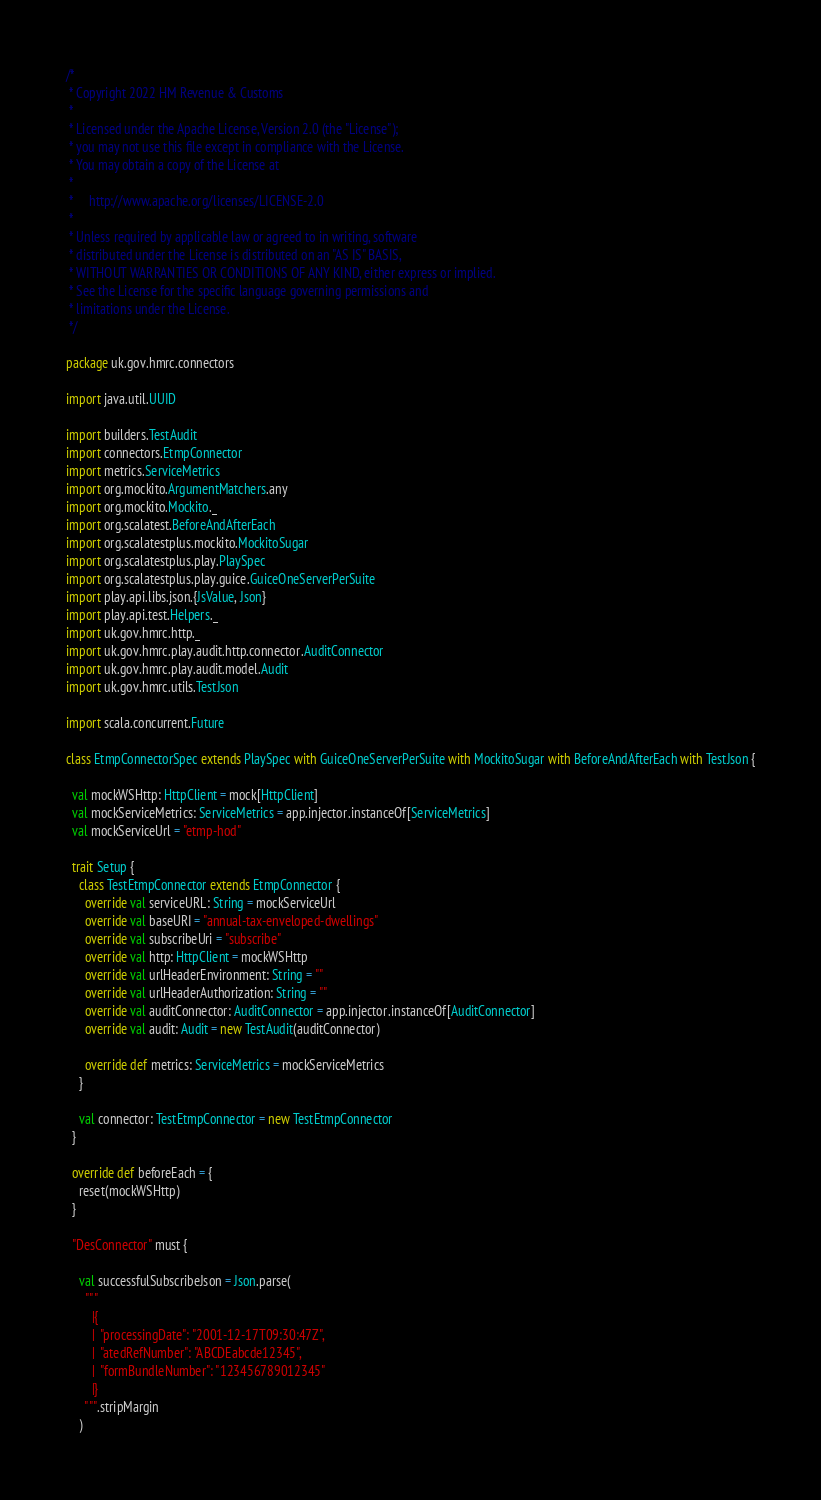Convert code to text. <code><loc_0><loc_0><loc_500><loc_500><_Scala_>/*
 * Copyright 2022 HM Revenue & Customs
 *
 * Licensed under the Apache License, Version 2.0 (the "License");
 * you may not use this file except in compliance with the License.
 * You may obtain a copy of the License at
 *
 *     http://www.apache.org/licenses/LICENSE-2.0
 *
 * Unless required by applicable law or agreed to in writing, software
 * distributed under the License is distributed on an "AS IS" BASIS,
 * WITHOUT WARRANTIES OR CONDITIONS OF ANY KIND, either express or implied.
 * See the License for the specific language governing permissions and
 * limitations under the License.
 */

package uk.gov.hmrc.connectors

import java.util.UUID

import builders.TestAudit
import connectors.EtmpConnector
import metrics.ServiceMetrics
import org.mockito.ArgumentMatchers.any
import org.mockito.Mockito._
import org.scalatest.BeforeAndAfterEach
import org.scalatestplus.mockito.MockitoSugar
import org.scalatestplus.play.PlaySpec
import org.scalatestplus.play.guice.GuiceOneServerPerSuite
import play.api.libs.json.{JsValue, Json}
import play.api.test.Helpers._
import uk.gov.hmrc.http._
import uk.gov.hmrc.play.audit.http.connector.AuditConnector
import uk.gov.hmrc.play.audit.model.Audit
import uk.gov.hmrc.utils.TestJson

import scala.concurrent.Future

class EtmpConnectorSpec extends PlaySpec with GuiceOneServerPerSuite with MockitoSugar with BeforeAndAfterEach with TestJson {

  val mockWSHttp: HttpClient = mock[HttpClient]
  val mockServiceMetrics: ServiceMetrics = app.injector.instanceOf[ServiceMetrics]
  val mockServiceUrl = "etmp-hod"

  trait Setup {
    class TestEtmpConnector extends EtmpConnector {
      override val serviceURL: String = mockServiceUrl
      override val baseURI = "annual-tax-enveloped-dwellings"
      override val subscribeUri = "subscribe"
      override val http: HttpClient = mockWSHttp
      override val urlHeaderEnvironment: String = ""
      override val urlHeaderAuthorization: String = ""
      override val auditConnector: AuditConnector = app.injector.instanceOf[AuditConnector]
      override val audit: Audit = new TestAudit(auditConnector)

      override def metrics: ServiceMetrics = mockServiceMetrics
    }

    val connector: TestEtmpConnector = new TestEtmpConnector
  }

  override def beforeEach = {
    reset(mockWSHttp)
  }

  "DesConnector" must {

    val successfulSubscribeJson = Json.parse(
      """
        |{
        |  "processingDate": "2001-12-17T09:30:47Z",
        |  "atedRefNumber": "ABCDEabcde12345",
        |  "formBundleNumber": "123456789012345"
        |}
      """.stripMargin
    )
</code> 